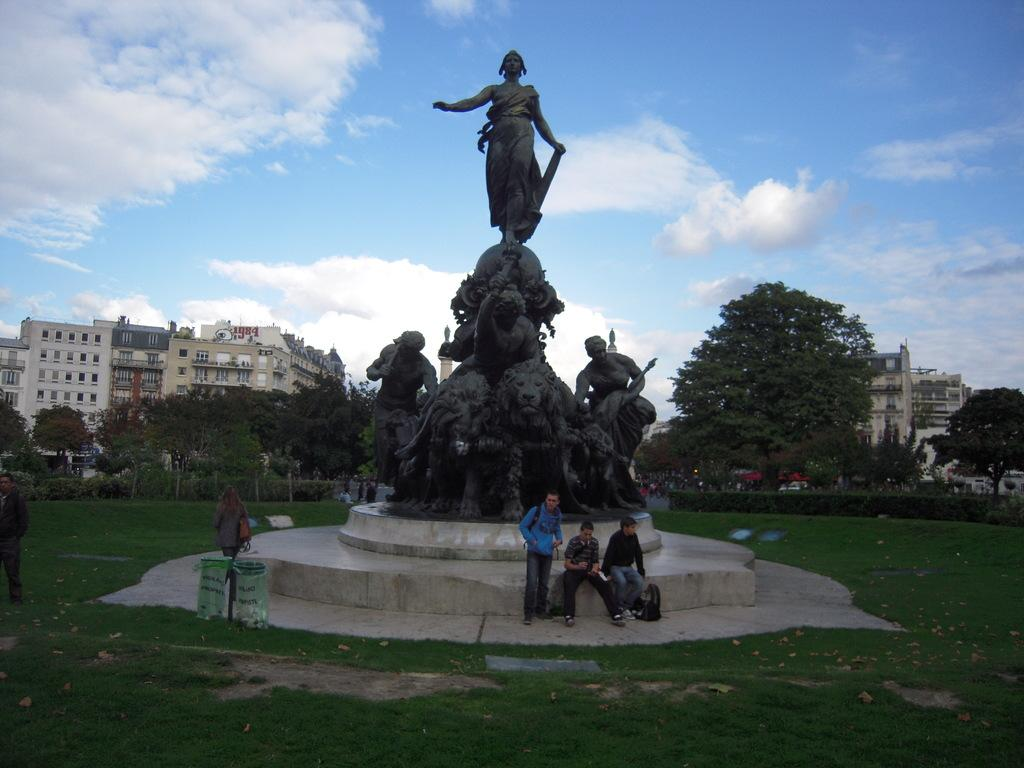What type of objects can be seen in the image? There are statues in the image. Are there any living beings present in the image? Yes, there are people in the image. What other elements can be seen in the image? There are plants, trees, buildings, grass, and the sky visible in the image. Can you describe the sky in the image? The sky is visible at the top of the image, and there are clouds in the sky. What type of pear is being used to control the minds of the people in the image? There is no pear or any mention of mind control in the image. The image features statues, people, plants, trees, buildings, grass, and a sky with clouds. 